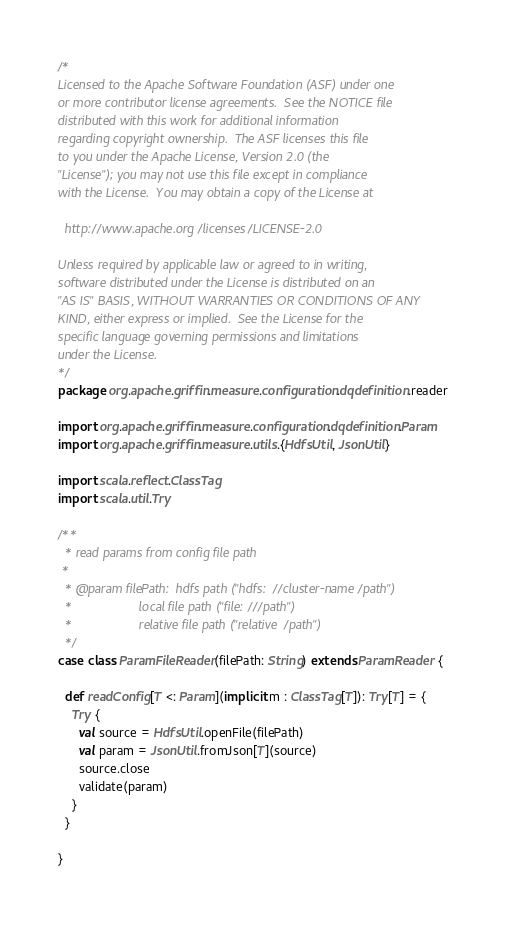Convert code to text. <code><loc_0><loc_0><loc_500><loc_500><_Scala_>/*
Licensed to the Apache Software Foundation (ASF) under one
or more contributor license agreements.  See the NOTICE file
distributed with this work for additional information
regarding copyright ownership.  The ASF licenses this file
to you under the Apache License, Version 2.0 (the
"License"); you may not use this file except in compliance
with the License.  You may obtain a copy of the License at

  http://www.apache.org/licenses/LICENSE-2.0

Unless required by applicable law or agreed to in writing,
software distributed under the License is distributed on an
"AS IS" BASIS, WITHOUT WARRANTIES OR CONDITIONS OF ANY
KIND, either express or implied.  See the License for the
specific language governing permissions and limitations
under the License.
*/
package org.apache.griffin.measure.configuration.dqdefinition.reader

import org.apache.griffin.measure.configuration.dqdefinition.Param
import org.apache.griffin.measure.utils.{HdfsUtil, JsonUtil}

import scala.reflect.ClassTag
import scala.util.Try

/**
  * read params from config file path
 *
  * @param filePath:  hdfs path ("hdfs://cluster-name/path")
  *                   local file path ("file:///path")
  *                   relative file path ("relative/path")
  */
case class ParamFileReader(filePath: String) extends ParamReader {

  def readConfig[T <: Param](implicit m : ClassTag[T]): Try[T] = {
    Try {
      val source = HdfsUtil.openFile(filePath)
      val param = JsonUtil.fromJson[T](source)
      source.close
      validate(param)
    }
  }

}
</code> 